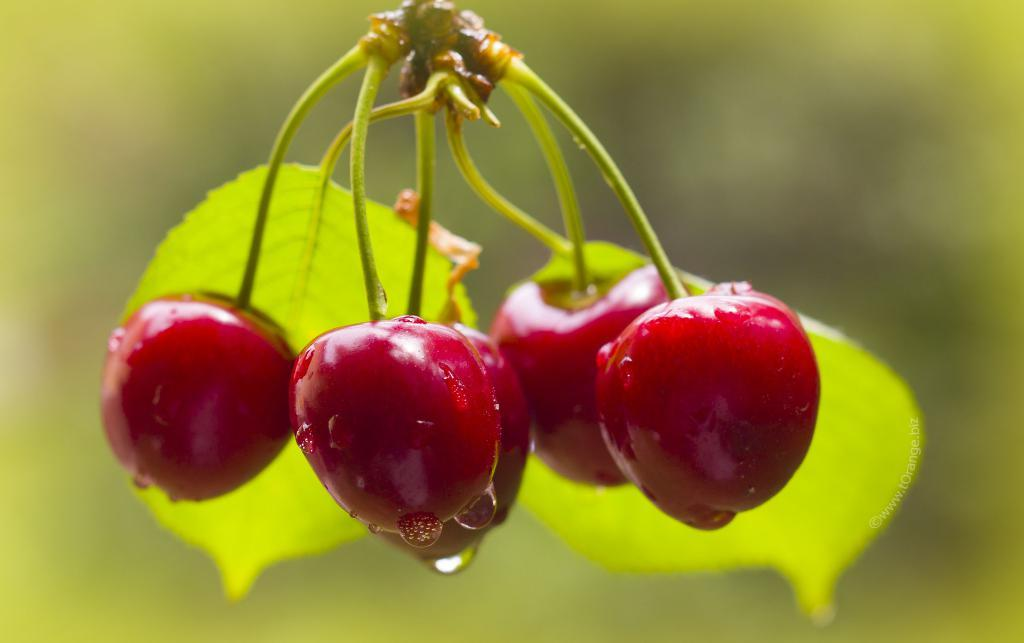What type of food can be seen in the image? There are fruits in the image. What is the condition of the fruits in the image? There are water drops on the fruits. What else is present in the image besides the fruits? There are leaves in the image. How would you describe the background of the image? The background of the image is blurred. What type of wine is being poured into the glass in the image? There is no glass or wine present in the image; it features fruits with water drops and leaves. How many balloons are visible in the image? There are no balloons present in the image. 